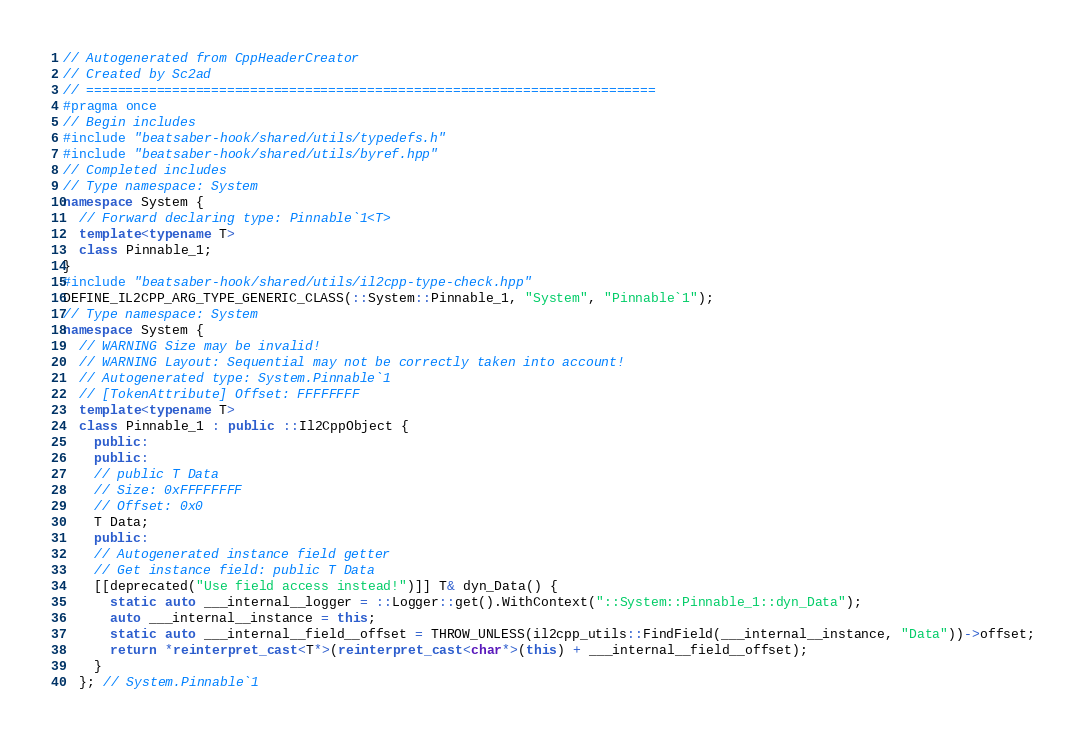<code> <loc_0><loc_0><loc_500><loc_500><_C++_>// Autogenerated from CppHeaderCreator
// Created by Sc2ad
// =========================================================================
#pragma once
// Begin includes
#include "beatsaber-hook/shared/utils/typedefs.h"
#include "beatsaber-hook/shared/utils/byref.hpp"
// Completed includes
// Type namespace: System
namespace System {
  // Forward declaring type: Pinnable`1<T>
  template<typename T>
  class Pinnable_1;
}
#include "beatsaber-hook/shared/utils/il2cpp-type-check.hpp"
DEFINE_IL2CPP_ARG_TYPE_GENERIC_CLASS(::System::Pinnable_1, "System", "Pinnable`1");
// Type namespace: System
namespace System {
  // WARNING Size may be invalid!
  // WARNING Layout: Sequential may not be correctly taken into account!
  // Autogenerated type: System.Pinnable`1
  // [TokenAttribute] Offset: FFFFFFFF
  template<typename T>
  class Pinnable_1 : public ::Il2CppObject {
    public:
    public:
    // public T Data
    // Size: 0xFFFFFFFF
    // Offset: 0x0
    T Data;
    public:
    // Autogenerated instance field getter
    // Get instance field: public T Data
    [[deprecated("Use field access instead!")]] T& dyn_Data() {
      static auto ___internal__logger = ::Logger::get().WithContext("::System::Pinnable_1::dyn_Data");
      auto ___internal__instance = this;
      static auto ___internal__field__offset = THROW_UNLESS(il2cpp_utils::FindField(___internal__instance, "Data"))->offset;
      return *reinterpret_cast<T*>(reinterpret_cast<char*>(this) + ___internal__field__offset);
    }
  }; // System.Pinnable`1</code> 